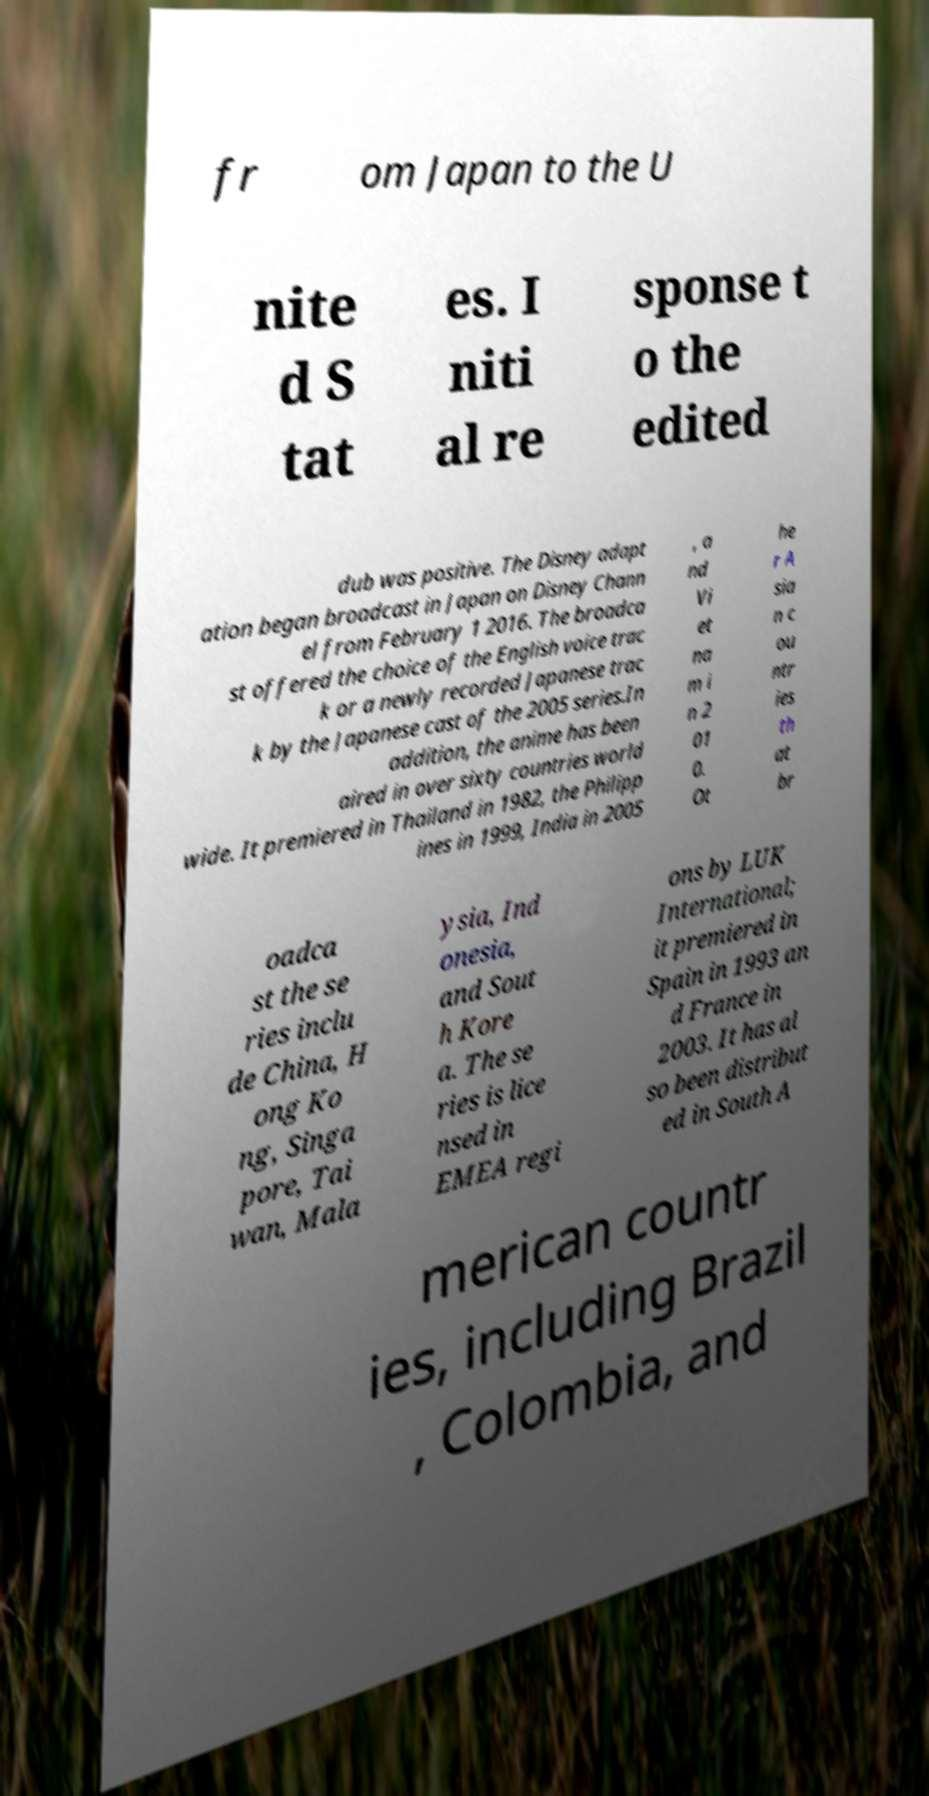For documentation purposes, I need the text within this image transcribed. Could you provide that? fr om Japan to the U nite d S tat es. I niti al re sponse t o the edited dub was positive. The Disney adapt ation began broadcast in Japan on Disney Chann el from February 1 2016. The broadca st offered the choice of the English voice trac k or a newly recorded Japanese trac k by the Japanese cast of the 2005 series.In addition, the anime has been aired in over sixty countries world wide. It premiered in Thailand in 1982, the Philipp ines in 1999, India in 2005 , a nd Vi et na m i n 2 01 0. Ot he r A sia n c ou ntr ies th at br oadca st the se ries inclu de China, H ong Ko ng, Singa pore, Tai wan, Mala ysia, Ind onesia, and Sout h Kore a. The se ries is lice nsed in EMEA regi ons by LUK International; it premiered in Spain in 1993 an d France in 2003. It has al so been distribut ed in South A merican countr ies, including Brazil , Colombia, and 